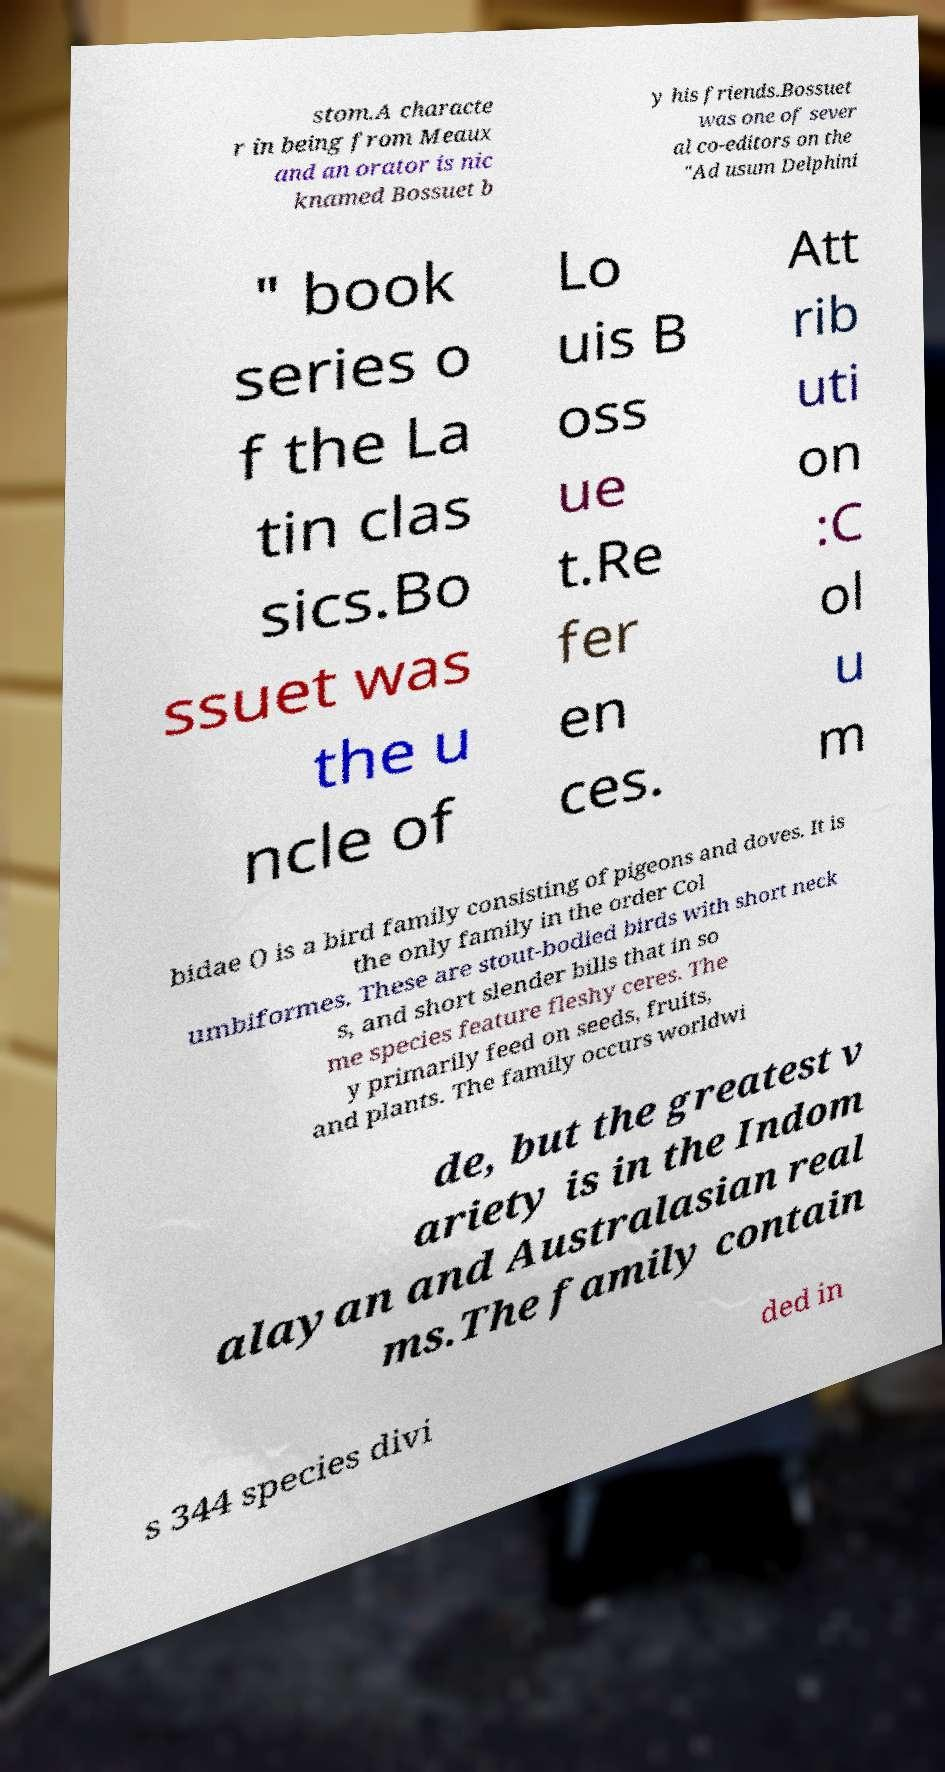There's text embedded in this image that I need extracted. Can you transcribe it verbatim? stom.A characte r in being from Meaux and an orator is nic knamed Bossuet b y his friends.Bossuet was one of sever al co-editors on the "Ad usum Delphini " book series o f the La tin clas sics.Bo ssuet was the u ncle of Lo uis B oss ue t.Re fer en ces. Att rib uti on :C ol u m bidae () is a bird family consisting of pigeons and doves. It is the only family in the order Col umbiformes. These are stout-bodied birds with short neck s, and short slender bills that in so me species feature fleshy ceres. The y primarily feed on seeds, fruits, and plants. The family occurs worldwi de, but the greatest v ariety is in the Indom alayan and Australasian real ms.The family contain s 344 species divi ded in 